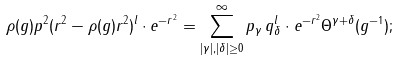Convert formula to latex. <formula><loc_0><loc_0><loc_500><loc_500>\rho ( g ) p ^ { 2 } ( r ^ { 2 } - \rho ( g ) r ^ { 2 } ) ^ { l } \cdot e ^ { - r ^ { 2 } } = \sum _ { | \gamma | , | \delta | \geq 0 } ^ { \infty } p _ { \gamma } \, q _ { \delta } ^ { l } \cdot e ^ { - r ^ { 2 } } \Theta ^ { \gamma + \delta } ( g ^ { - 1 } ) ;</formula> 